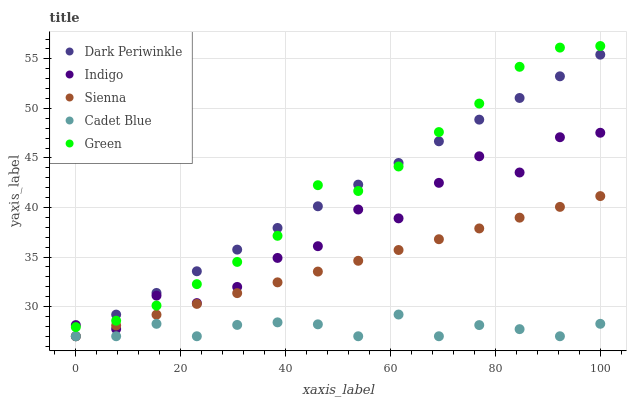Does Cadet Blue have the minimum area under the curve?
Answer yes or no. Yes. Does Green have the maximum area under the curve?
Answer yes or no. Yes. Does Green have the minimum area under the curve?
Answer yes or no. No. Does Cadet Blue have the maximum area under the curve?
Answer yes or no. No. Is Sienna the smoothest?
Answer yes or no. Yes. Is Indigo the roughest?
Answer yes or no. Yes. Is Green the smoothest?
Answer yes or no. No. Is Green the roughest?
Answer yes or no. No. Does Sienna have the lowest value?
Answer yes or no. Yes. Does Green have the lowest value?
Answer yes or no. No. Does Green have the highest value?
Answer yes or no. Yes. Does Cadet Blue have the highest value?
Answer yes or no. No. Is Sienna less than Green?
Answer yes or no. Yes. Is Green greater than Sienna?
Answer yes or no. Yes. Does Sienna intersect Dark Periwinkle?
Answer yes or no. Yes. Is Sienna less than Dark Periwinkle?
Answer yes or no. No. Is Sienna greater than Dark Periwinkle?
Answer yes or no. No. Does Sienna intersect Green?
Answer yes or no. No. 